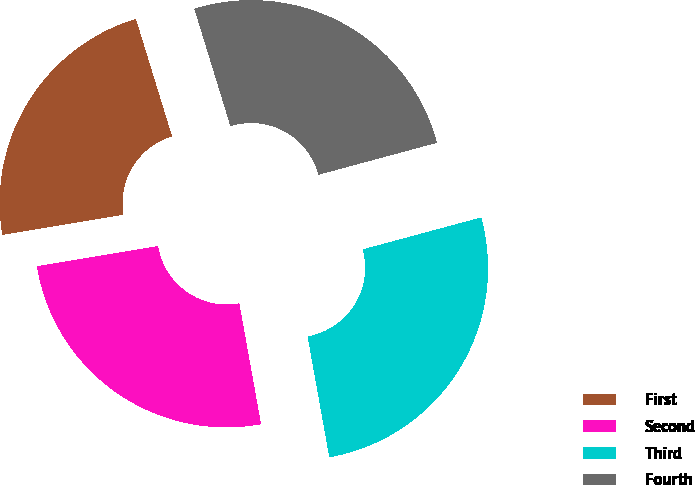Convert chart. <chart><loc_0><loc_0><loc_500><loc_500><pie_chart><fcel>First<fcel>Second<fcel>Third<fcel>Fourth<nl><fcel>22.88%<fcel>25.2%<fcel>26.36%<fcel>25.55%<nl></chart> 